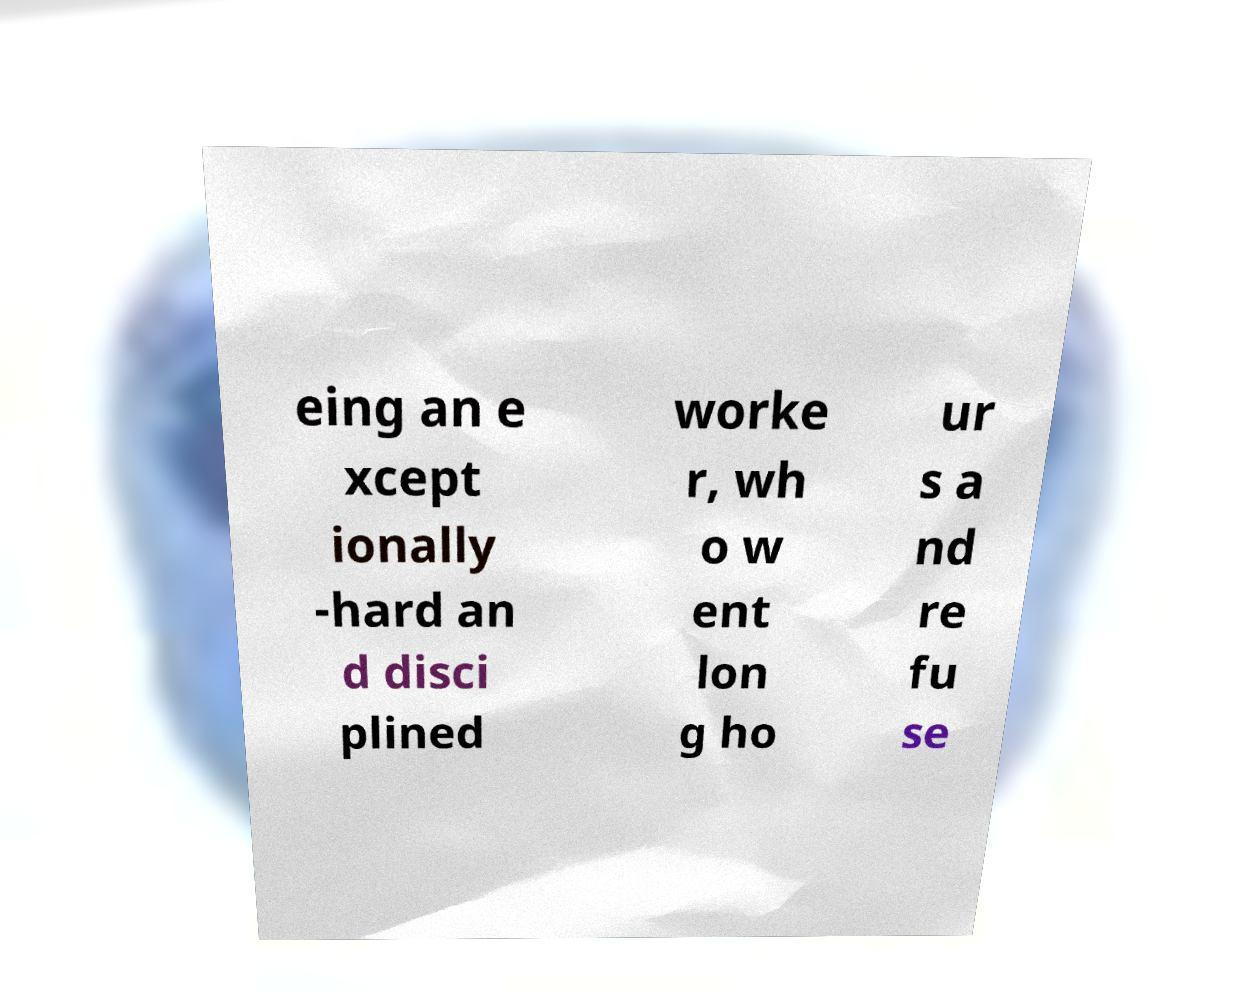What messages or text are displayed in this image? I need them in a readable, typed format. eing an e xcept ionally -hard an d disci plined worke r, wh o w ent lon g ho ur s a nd re fu se 